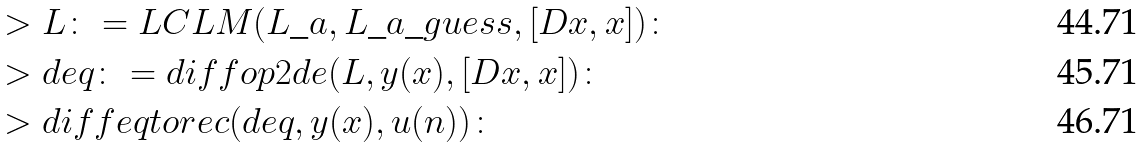<formula> <loc_0><loc_0><loc_500><loc_500>& > L \colon = L C L M ( L \_ a , L \_ a \_ g u e s s , [ D x , x ] ) \colon \\ & > d e q \colon = d i f f o p 2 d e ( L , y ( x ) , [ D x , x ] ) \colon \\ & > d i f f e q t o r e c ( d e q , y ( x ) , u ( n ) ) \colon</formula> 